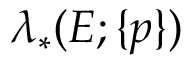Convert formula to latex. <formula><loc_0><loc_0><loc_500><loc_500>\lambda _ { * } ( E ; \{ p \} )</formula> 